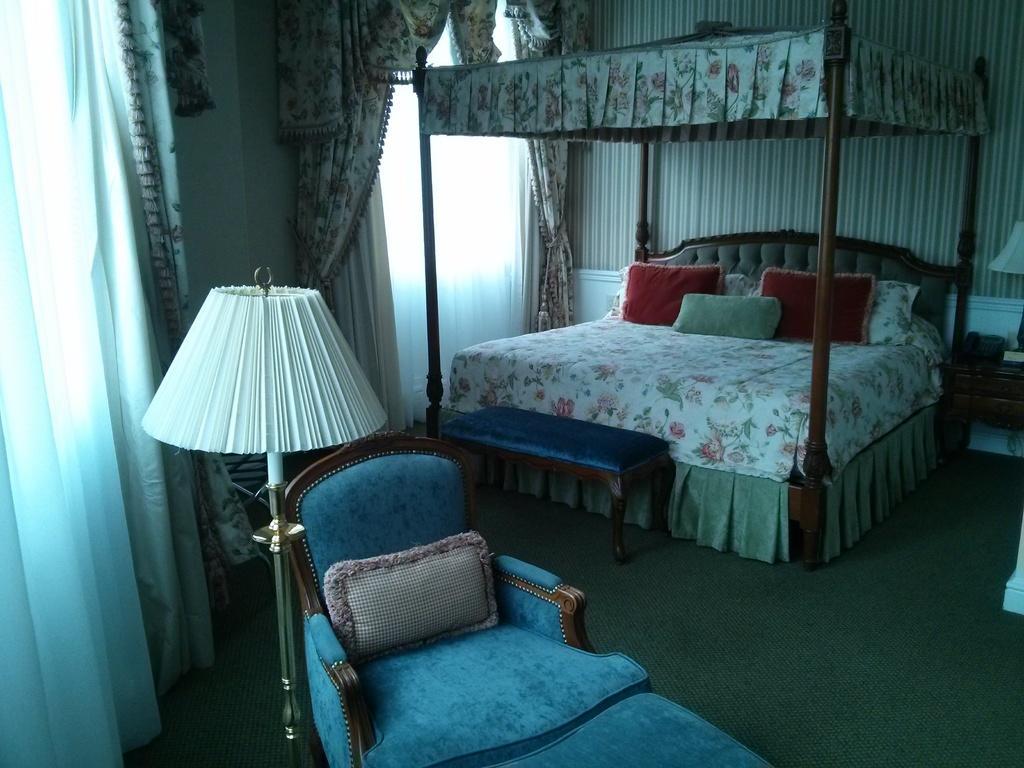Please provide a concise description of this image. This is an inner view of the room where we can see bed, chair, lamp and curtains on the windows. 